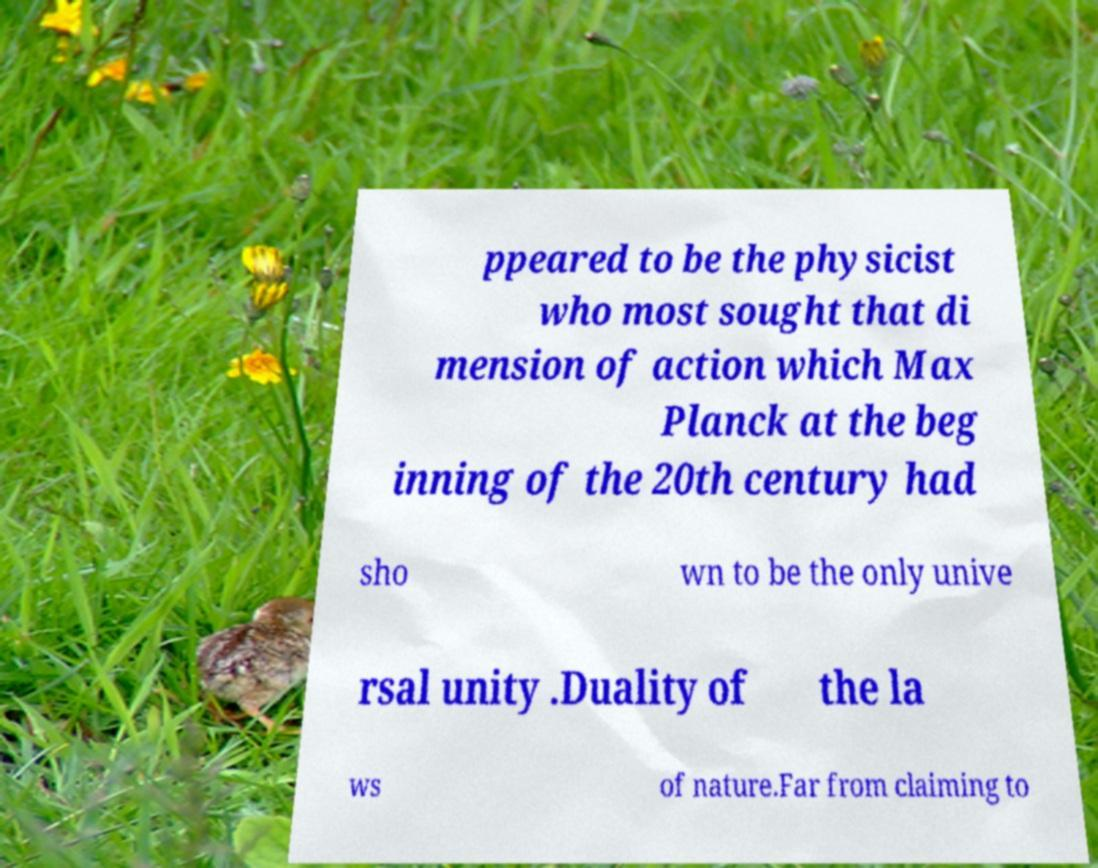Can you read and provide the text displayed in the image?This photo seems to have some interesting text. Can you extract and type it out for me? ppeared to be the physicist who most sought that di mension of action which Max Planck at the beg inning of the 20th century had sho wn to be the only unive rsal unity .Duality of the la ws of nature.Far from claiming to 